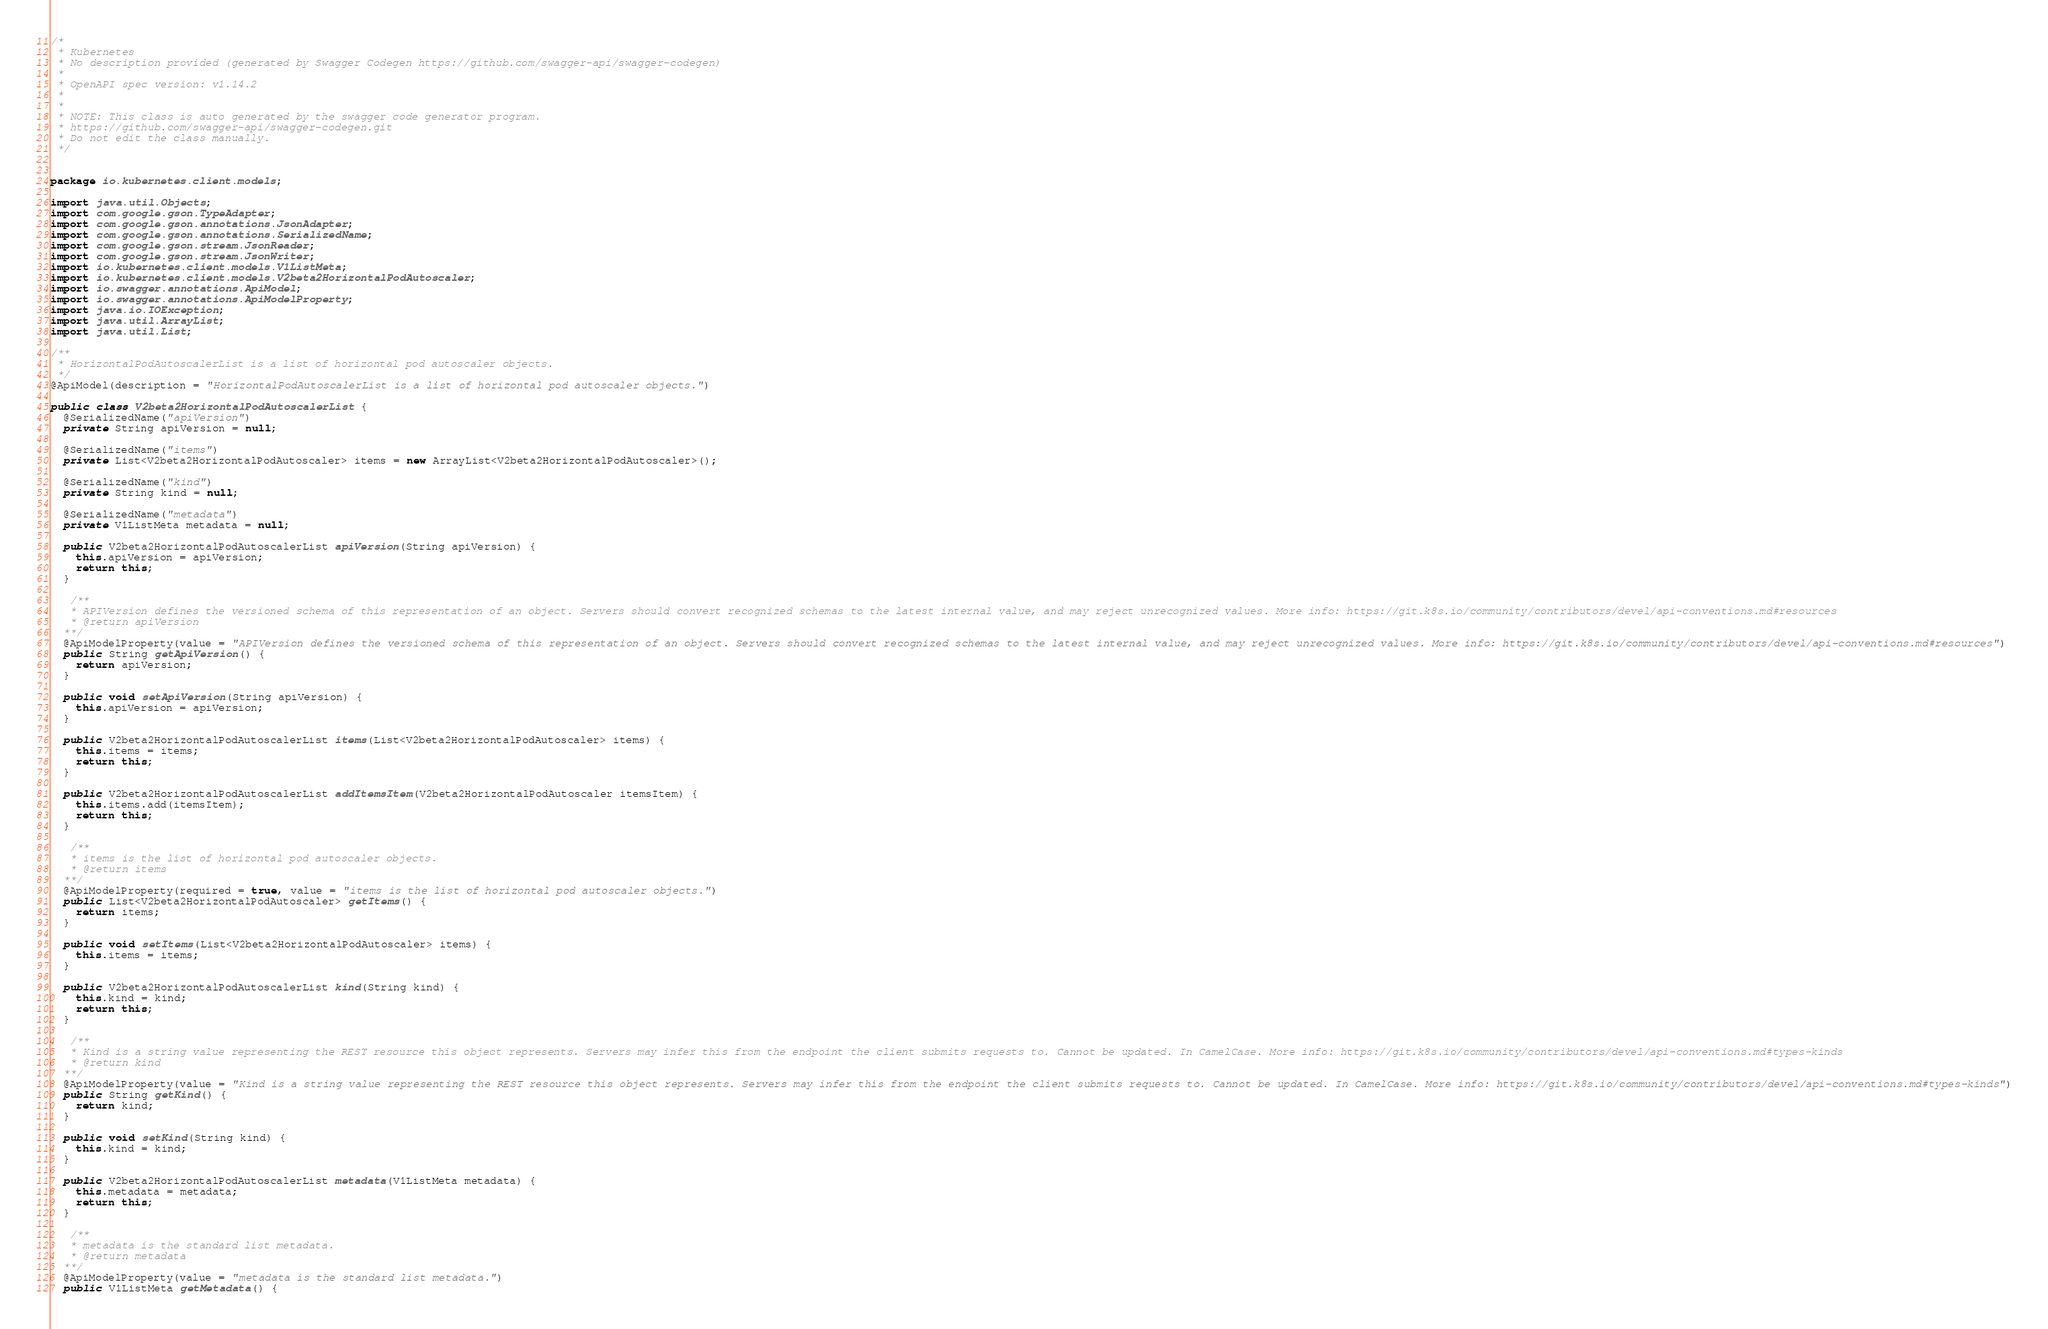Convert code to text. <code><loc_0><loc_0><loc_500><loc_500><_Java_>/*
 * Kubernetes
 * No description provided (generated by Swagger Codegen https://github.com/swagger-api/swagger-codegen)
 *
 * OpenAPI spec version: v1.14.2
 * 
 *
 * NOTE: This class is auto generated by the swagger code generator program.
 * https://github.com/swagger-api/swagger-codegen.git
 * Do not edit the class manually.
 */


package io.kubernetes.client.models;

import java.util.Objects;
import com.google.gson.TypeAdapter;
import com.google.gson.annotations.JsonAdapter;
import com.google.gson.annotations.SerializedName;
import com.google.gson.stream.JsonReader;
import com.google.gson.stream.JsonWriter;
import io.kubernetes.client.models.V1ListMeta;
import io.kubernetes.client.models.V2beta2HorizontalPodAutoscaler;
import io.swagger.annotations.ApiModel;
import io.swagger.annotations.ApiModelProperty;
import java.io.IOException;
import java.util.ArrayList;
import java.util.List;

/**
 * HorizontalPodAutoscalerList is a list of horizontal pod autoscaler objects.
 */
@ApiModel(description = "HorizontalPodAutoscalerList is a list of horizontal pod autoscaler objects.")

public class V2beta2HorizontalPodAutoscalerList {
  @SerializedName("apiVersion")
  private String apiVersion = null;

  @SerializedName("items")
  private List<V2beta2HorizontalPodAutoscaler> items = new ArrayList<V2beta2HorizontalPodAutoscaler>();

  @SerializedName("kind")
  private String kind = null;

  @SerializedName("metadata")
  private V1ListMeta metadata = null;

  public V2beta2HorizontalPodAutoscalerList apiVersion(String apiVersion) {
    this.apiVersion = apiVersion;
    return this;
  }

   /**
   * APIVersion defines the versioned schema of this representation of an object. Servers should convert recognized schemas to the latest internal value, and may reject unrecognized values. More info: https://git.k8s.io/community/contributors/devel/api-conventions.md#resources
   * @return apiVersion
  **/
  @ApiModelProperty(value = "APIVersion defines the versioned schema of this representation of an object. Servers should convert recognized schemas to the latest internal value, and may reject unrecognized values. More info: https://git.k8s.io/community/contributors/devel/api-conventions.md#resources")
  public String getApiVersion() {
    return apiVersion;
  }

  public void setApiVersion(String apiVersion) {
    this.apiVersion = apiVersion;
  }

  public V2beta2HorizontalPodAutoscalerList items(List<V2beta2HorizontalPodAutoscaler> items) {
    this.items = items;
    return this;
  }

  public V2beta2HorizontalPodAutoscalerList addItemsItem(V2beta2HorizontalPodAutoscaler itemsItem) {
    this.items.add(itemsItem);
    return this;
  }

   /**
   * items is the list of horizontal pod autoscaler objects.
   * @return items
  **/
  @ApiModelProperty(required = true, value = "items is the list of horizontal pod autoscaler objects.")
  public List<V2beta2HorizontalPodAutoscaler> getItems() {
    return items;
  }

  public void setItems(List<V2beta2HorizontalPodAutoscaler> items) {
    this.items = items;
  }

  public V2beta2HorizontalPodAutoscalerList kind(String kind) {
    this.kind = kind;
    return this;
  }

   /**
   * Kind is a string value representing the REST resource this object represents. Servers may infer this from the endpoint the client submits requests to. Cannot be updated. In CamelCase. More info: https://git.k8s.io/community/contributors/devel/api-conventions.md#types-kinds
   * @return kind
  **/
  @ApiModelProperty(value = "Kind is a string value representing the REST resource this object represents. Servers may infer this from the endpoint the client submits requests to. Cannot be updated. In CamelCase. More info: https://git.k8s.io/community/contributors/devel/api-conventions.md#types-kinds")
  public String getKind() {
    return kind;
  }

  public void setKind(String kind) {
    this.kind = kind;
  }

  public V2beta2HorizontalPodAutoscalerList metadata(V1ListMeta metadata) {
    this.metadata = metadata;
    return this;
  }

   /**
   * metadata is the standard list metadata.
   * @return metadata
  **/
  @ApiModelProperty(value = "metadata is the standard list metadata.")
  public V1ListMeta getMetadata() {</code> 